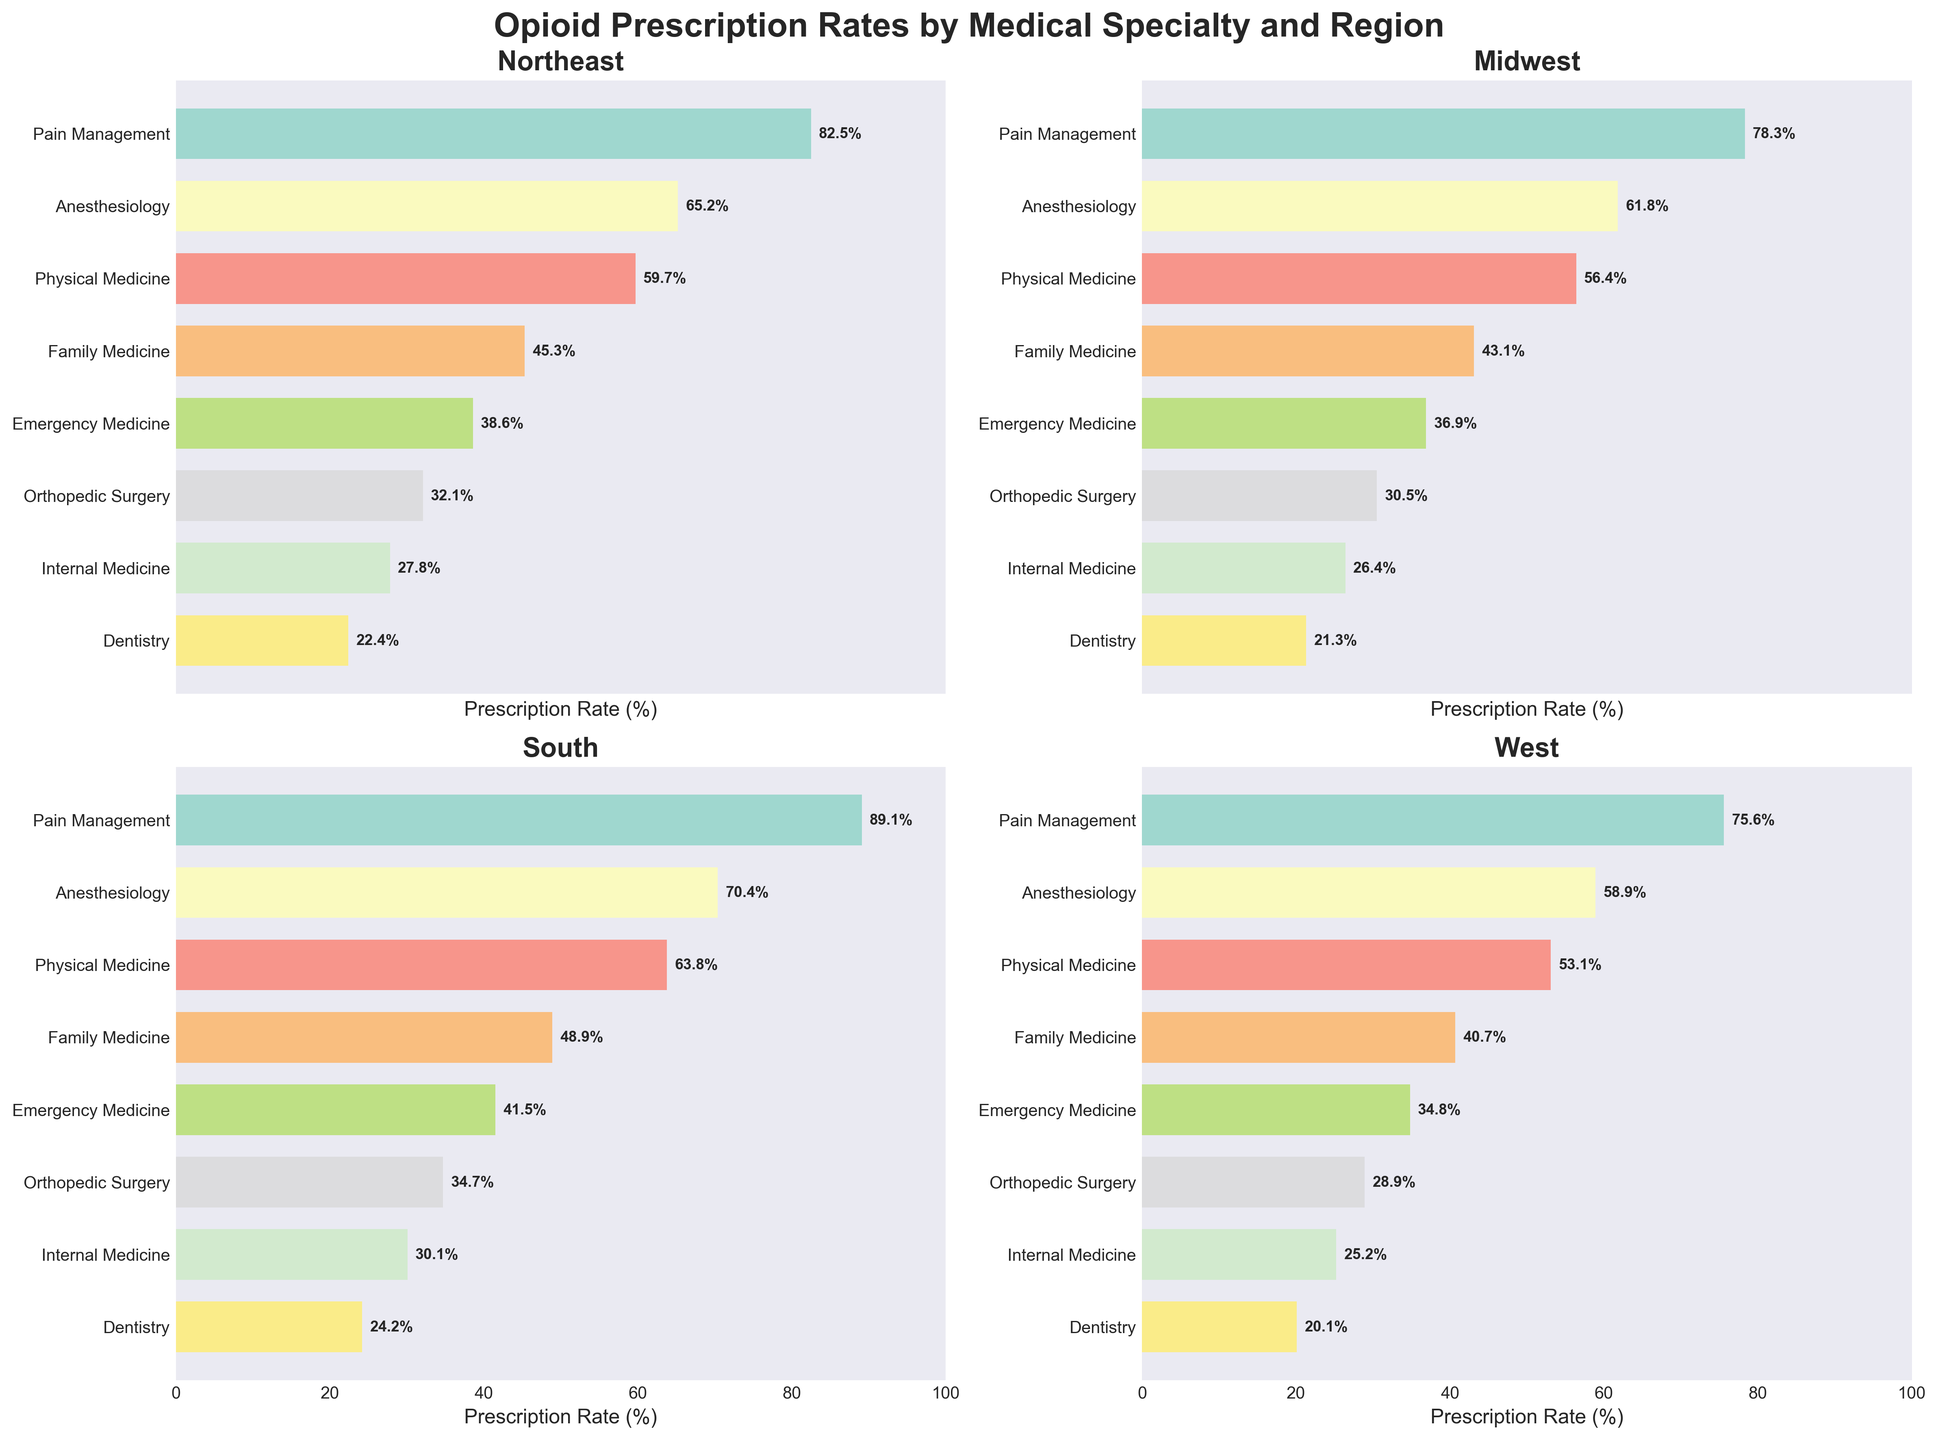What is the title of the figure? The title is written at the top center of the figure and indicates the main focus of the visual representation. The title specifies the topic covered by the visual elements.
Answer: Opioid Prescription Rates by Medical Specialty and Region How many medical specialties are displayed in the figure? Each subplot has vertical labels on the left side indicating different medical specialties. Count these labels to determine the number of specialties shown.
Answer: 8 Which region has the highest opioid prescription rate for Pain Management? Look at each of the four subplots, locate the bar corresponding to Pain Management, and compare the prescription rates. The highest rate will have the longest bar in its respective region.
Answer: South What's the total prescription rate for Anesthesiology across all regions? Sum the prescription rates for Anesthesiology from each of the four subplots: Northeast (65.2), Midwest (61.8), South (70.4), and West (58.9). The sum provides the total prescription rate.
Answer: 256.3 Which medical specialty has the lowest prescription rate in the West region? Look at the subplot for the West, find the shortest bar, and identify the corresponding specialty. This specialty has the lowest prescription rate in the West.
Answer: Dentistry Are the opioid prescription rates higher in the South or the Northeast for Emergency Medicine? Compare the lengths of the bars representing Emergency Medicine in the South and Northeast subplots. The region with the longer bar has a higher rate.
Answer: South What's the difference in opioid prescription rates between Family Medicine in the Midwest and Pain Management in the West? Find the rates for Family Medicine in the Midwest (43.1) and Pain Management in the West (75.6) and calculate the difference by subtracting the two values.
Answer: 32.5 Which region observes the most significant variation in opioid prescription rates across different specialties? Evaluate the range of prescription rates (difference between the highest and lowest rates) for each region's subplot. The region with the largest range has the most significant variation.
Answer: South In the Northeast, how much higher is the prescription rate for Pain Management compared to Orthopedic Surgery? Find the prescription rates for Pain Management (82.5) and Orthopedic Surgery (32.1) in the Northeast; subtract the Orthopedic Surgery rate from the Pain Management rate.
Answer: 50.4 